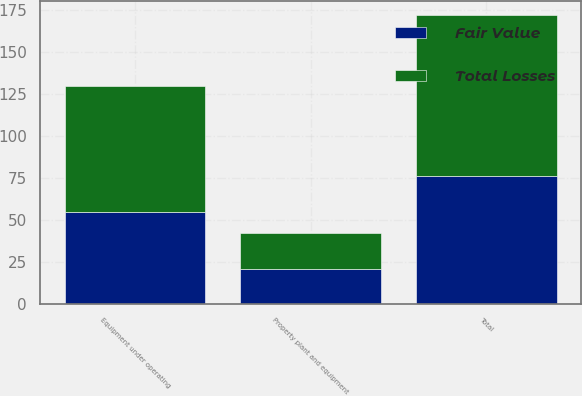Convert chart. <chart><loc_0><loc_0><loc_500><loc_500><stacked_bar_chart><ecel><fcel>Equipment under operating<fcel>Property plant and equipment<fcel>Total<nl><fcel>Total Losses<fcel>75<fcel>21<fcel>96<nl><fcel>Fair Value<fcel>55<fcel>21<fcel>76<nl></chart> 